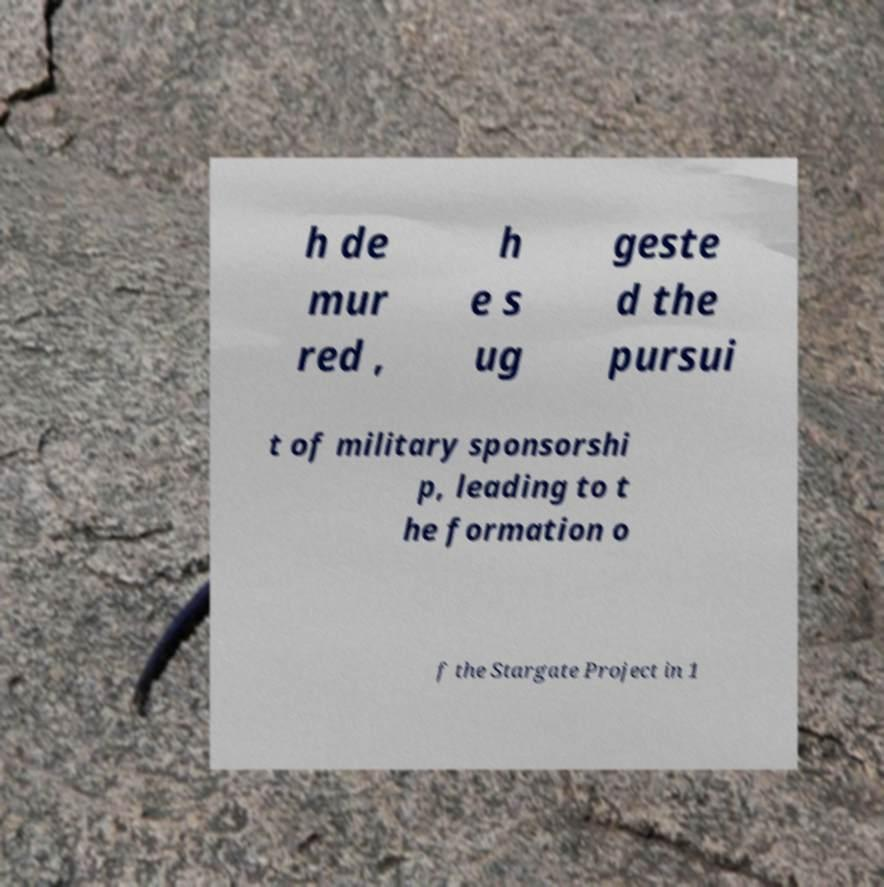Could you assist in decoding the text presented in this image and type it out clearly? h de mur red , h e s ug geste d the pursui t of military sponsorshi p, leading to t he formation o f the Stargate Project in 1 